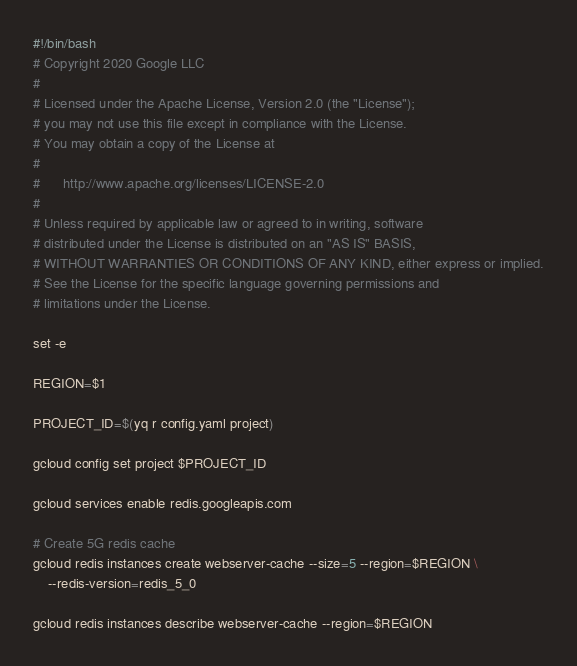Convert code to text. <code><loc_0><loc_0><loc_500><loc_500><_Bash_>#!/bin/bash
# Copyright 2020 Google LLC
#
# Licensed under the Apache License, Version 2.0 (the "License");
# you may not use this file except in compliance with the License.
# You may obtain a copy of the License at
#
#      http://www.apache.org/licenses/LICENSE-2.0
#
# Unless required by applicable law or agreed to in writing, software
# distributed under the License is distributed on an "AS IS" BASIS,
# WITHOUT WARRANTIES OR CONDITIONS OF ANY KIND, either express or implied.
# See the License for the specific language governing permissions and
# limitations under the License.

set -e

REGION=$1

PROJECT_ID=$(yq r config.yaml project)

gcloud config set project $PROJECT_ID

gcloud services enable redis.googleapis.com

# Create 5G redis cache
gcloud redis instances create webserver-cache --size=5 --region=$REGION \
    --redis-version=redis_5_0

gcloud redis instances describe webserver-cache --region=$REGION</code> 